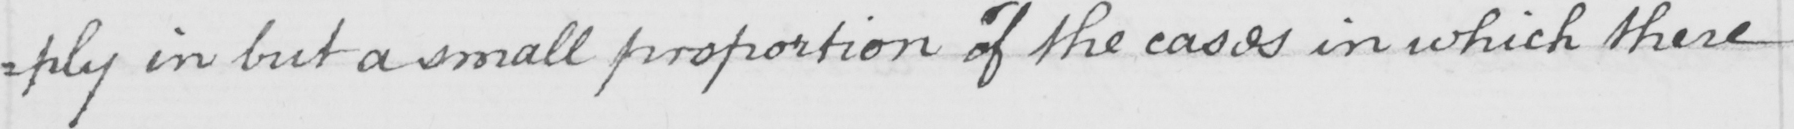What text is written in this handwritten line? =ply in but a small proportion of the cases in which there 